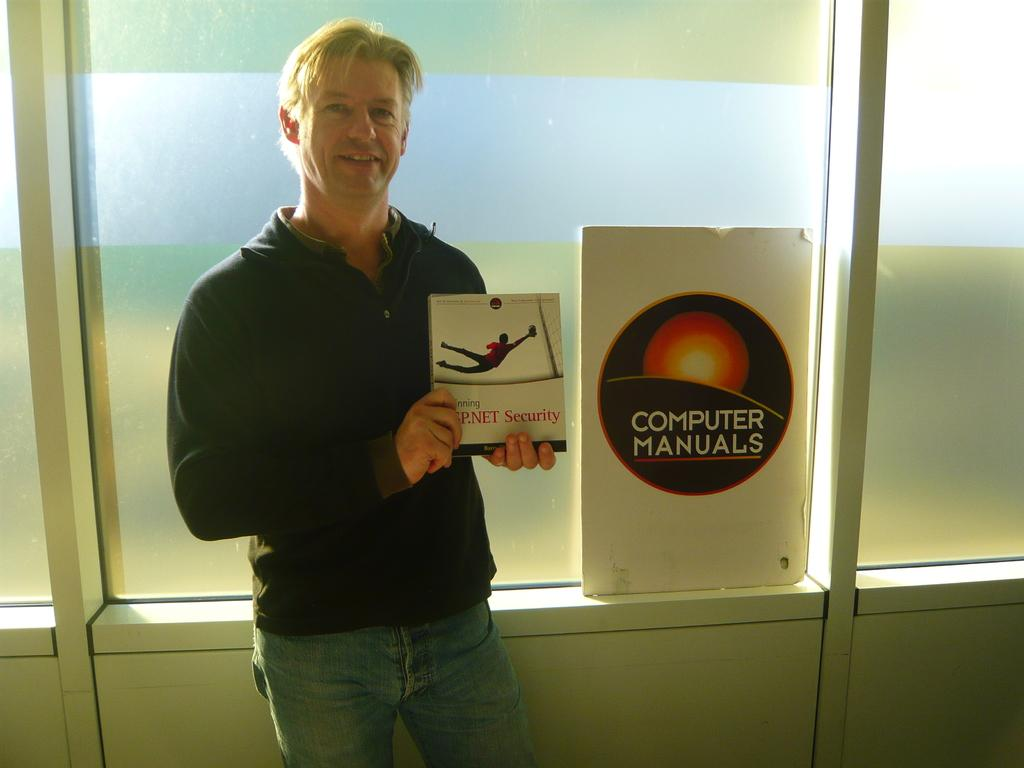<image>
Relay a brief, clear account of the picture shown. A man holding a book stands next to a poster labelled "Computer Manuals." 